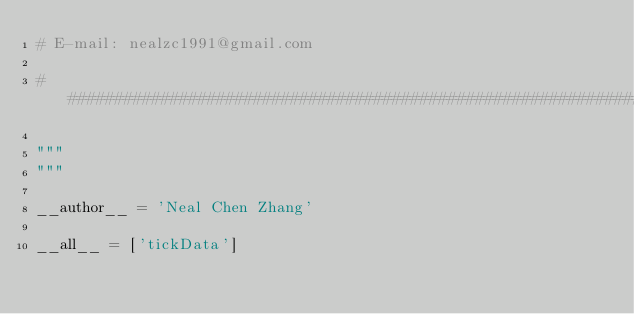<code> <loc_0><loc_0><loc_500><loc_500><_Python_># E-mail: nealzc1991@gmail.com

###############################################################################

"""
"""

__author__ = 'Neal Chen Zhang'

__all__ = ['tickData']
</code> 